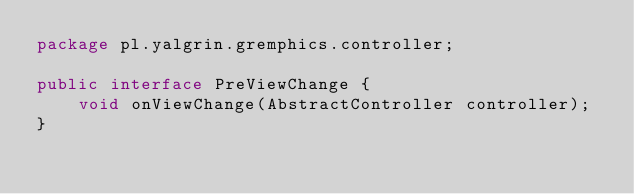<code> <loc_0><loc_0><loc_500><loc_500><_Java_>package pl.yalgrin.gremphics.controller;

public interface PreViewChange {
    void onViewChange(AbstractController controller);
}
</code> 